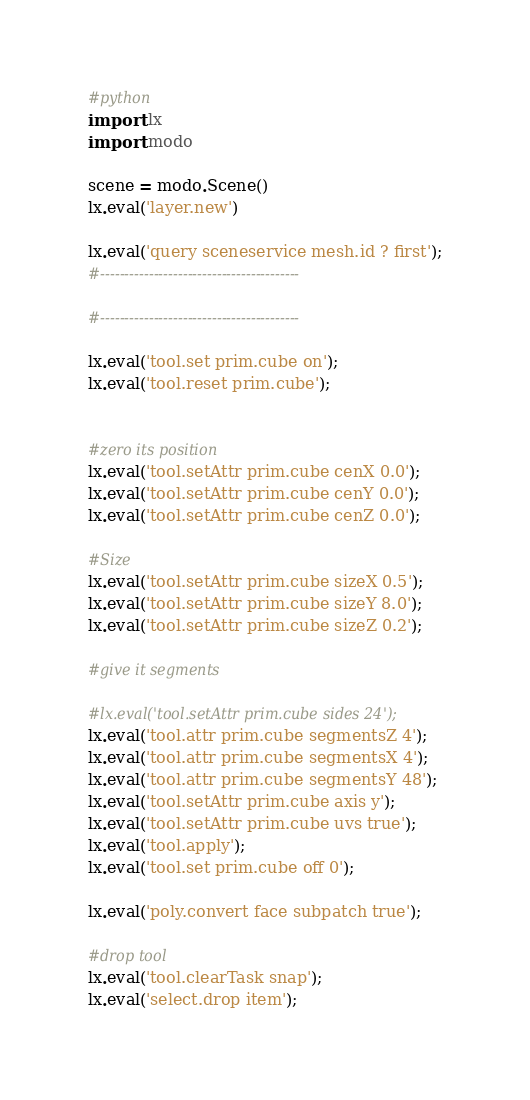<code> <loc_0><loc_0><loc_500><loc_500><_Python_>#python
import lx
import modo

scene = modo.Scene()
lx.eval('layer.new')

lx.eval('query sceneservice mesh.id ? first');
#-----------------------------------------

#-----------------------------------------

lx.eval('tool.set prim.cube on');
lx.eval('tool.reset prim.cube');


#zero its position
lx.eval('tool.setAttr prim.cube cenX 0.0');
lx.eval('tool.setAttr prim.cube cenY 0.0');
lx.eval('tool.setAttr prim.cube cenZ 0.0');

#Size
lx.eval('tool.setAttr prim.cube sizeX 0.5');
lx.eval('tool.setAttr prim.cube sizeY 8.0');
lx.eval('tool.setAttr prim.cube sizeZ 0.2');

#give it segments

#lx.eval('tool.setAttr prim.cube sides 24');
lx.eval('tool.attr prim.cube segmentsZ 4');
lx.eval('tool.attr prim.cube segmentsX 4');
lx.eval('tool.attr prim.cube segmentsY 48');
lx.eval('tool.setAttr prim.cube axis y');
lx.eval('tool.setAttr prim.cube uvs true');
lx.eval('tool.apply');
lx.eval('tool.set prim.cube off 0');

lx.eval('poly.convert face subpatch true');

#drop tool 
lx.eval('tool.clearTask snap');
lx.eval('select.drop item');




</code> 